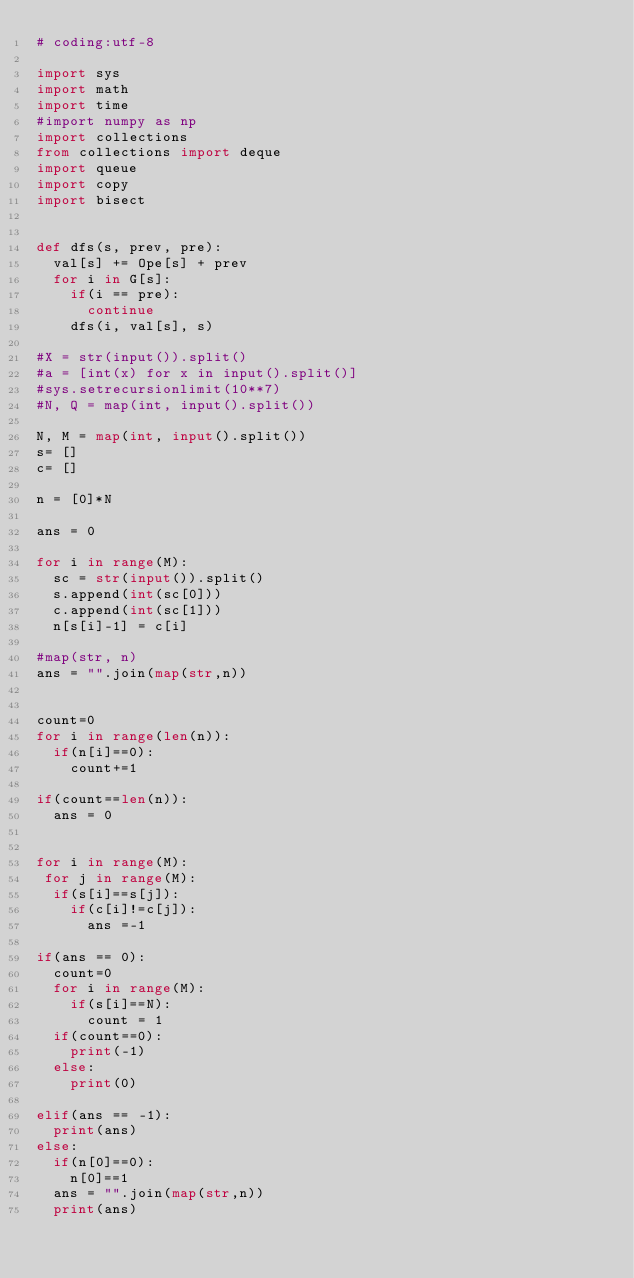Convert code to text. <code><loc_0><loc_0><loc_500><loc_500><_Python_># coding:utf-8

import sys
import math
import time
#import numpy as np
import collections
from collections import deque
import queue
import copy
import bisect


def dfs(s, prev, pre):
  val[s] += Ope[s] + prev
  for i in G[s]:
    if(i == pre):
      continue
    dfs(i, val[s], s)

#X = str(input()).split()
#a = [int(x) for x in input().split()]
#sys.setrecursionlimit(10**7)
#N, Q = map(int, input().split())

N, M = map(int, input().split())
s= []
c= []

n = [0]*N

ans = 0

for i in range(M):
  sc = str(input()).split()
  s.append(int(sc[0]))
  c.append(int(sc[1]))
  n[s[i]-1] = c[i]

#map(str, n)
ans = "".join(map(str,n))


count=0
for i in range(len(n)):
  if(n[i]==0):
    count+=1

if(count==len(n)):
  ans = 0


for i in range(M):
 for j in range(M):
  if(s[i]==s[j]):
    if(c[i]!=c[j]):
      ans =-1

if(ans == 0):
  count=0
  for i in range(M):
    if(s[i]==N):
      count = 1
  if(count==0):
    print(-1)
  else:
    print(0)

elif(ans == -1):
  print(ans)
else:
  if(n[0]==0):
    n[0]==1
  ans = "".join(map(str,n))
  print(ans)


</code> 